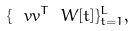Convert formula to latex. <formula><loc_0><loc_0><loc_500><loc_500>\{ \ v v ^ { T } \ W [ t ] \} _ { t = 1 } ^ { L } ,</formula> 